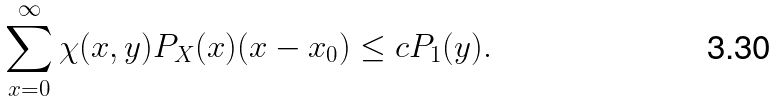Convert formula to latex. <formula><loc_0><loc_0><loc_500><loc_500>\sum _ { x = 0 } ^ { \infty } \chi ( x , y ) P _ { X } ( x ) ( x - x _ { 0 } ) \leq c P _ { 1 } ( y ) .</formula> 